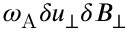Convert formula to latex. <formula><loc_0><loc_0><loc_500><loc_500>\omega _ { A } \delta u _ { \perp } \delta B _ { \perp }</formula> 